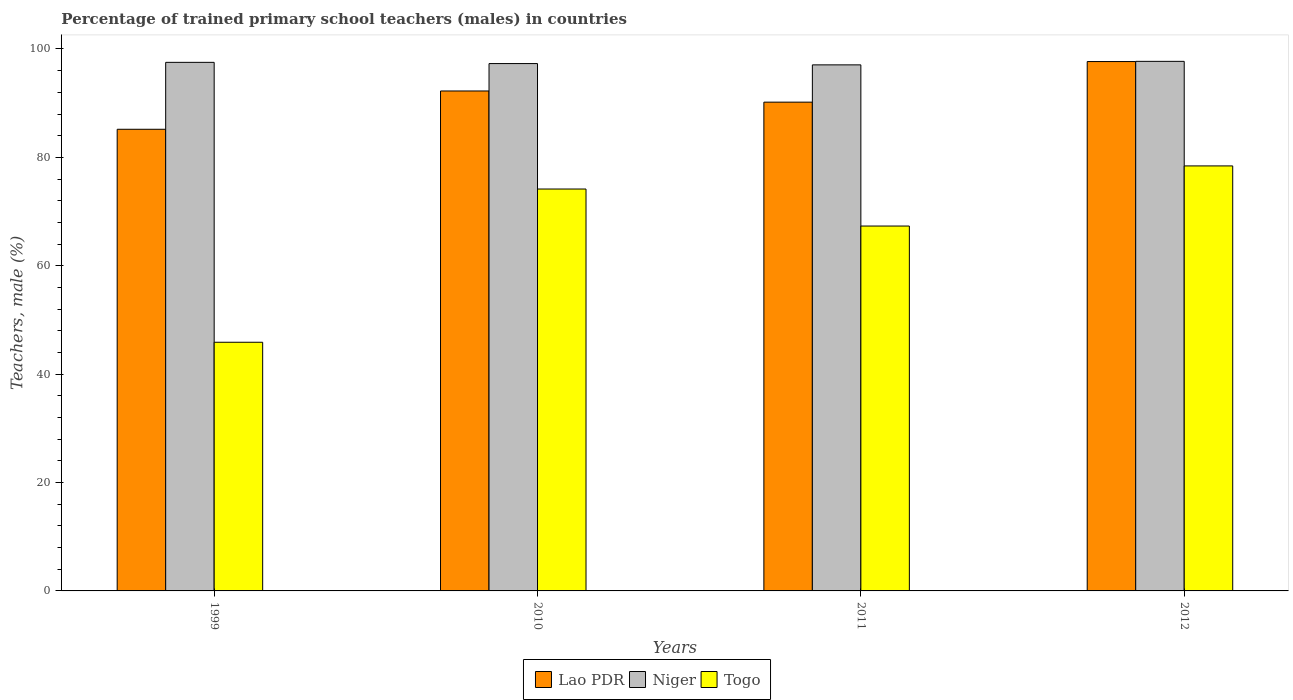How many groups of bars are there?
Your response must be concise. 4. How many bars are there on the 3rd tick from the left?
Make the answer very short. 3. How many bars are there on the 1st tick from the right?
Your response must be concise. 3. What is the label of the 1st group of bars from the left?
Your answer should be compact. 1999. In how many cases, is the number of bars for a given year not equal to the number of legend labels?
Provide a short and direct response. 0. What is the percentage of trained primary school teachers (males) in Niger in 1999?
Give a very brief answer. 97.53. Across all years, what is the maximum percentage of trained primary school teachers (males) in Niger?
Give a very brief answer. 97.72. Across all years, what is the minimum percentage of trained primary school teachers (males) in Togo?
Make the answer very short. 45.88. In which year was the percentage of trained primary school teachers (males) in Niger minimum?
Make the answer very short. 2011. What is the total percentage of trained primary school teachers (males) in Niger in the graph?
Offer a terse response. 389.64. What is the difference between the percentage of trained primary school teachers (males) in Togo in 1999 and that in 2011?
Offer a terse response. -21.45. What is the difference between the percentage of trained primary school teachers (males) in Niger in 2010 and the percentage of trained primary school teachers (males) in Togo in 1999?
Make the answer very short. 51.43. What is the average percentage of trained primary school teachers (males) in Niger per year?
Ensure brevity in your answer.  97.41. In the year 2012, what is the difference between the percentage of trained primary school teachers (males) in Niger and percentage of trained primary school teachers (males) in Lao PDR?
Your answer should be very brief. 0.04. In how many years, is the percentage of trained primary school teachers (males) in Niger greater than 12 %?
Your answer should be very brief. 4. What is the ratio of the percentage of trained primary school teachers (males) in Togo in 2010 to that in 2011?
Ensure brevity in your answer.  1.1. Is the difference between the percentage of trained primary school teachers (males) in Niger in 2010 and 2012 greater than the difference between the percentage of trained primary school teachers (males) in Lao PDR in 2010 and 2012?
Your answer should be compact. Yes. What is the difference between the highest and the second highest percentage of trained primary school teachers (males) in Togo?
Your response must be concise. 4.26. What is the difference between the highest and the lowest percentage of trained primary school teachers (males) in Niger?
Your answer should be very brief. 0.65. What does the 3rd bar from the left in 1999 represents?
Give a very brief answer. Togo. What does the 3rd bar from the right in 2011 represents?
Your response must be concise. Lao PDR. Is it the case that in every year, the sum of the percentage of trained primary school teachers (males) in Lao PDR and percentage of trained primary school teachers (males) in Niger is greater than the percentage of trained primary school teachers (males) in Togo?
Offer a very short reply. Yes. Are all the bars in the graph horizontal?
Keep it short and to the point. No. How many years are there in the graph?
Offer a very short reply. 4. Does the graph contain any zero values?
Offer a terse response. No. Does the graph contain grids?
Your answer should be very brief. No. Where does the legend appear in the graph?
Give a very brief answer. Bottom center. How are the legend labels stacked?
Provide a succinct answer. Horizontal. What is the title of the graph?
Keep it short and to the point. Percentage of trained primary school teachers (males) in countries. Does "Cyprus" appear as one of the legend labels in the graph?
Your answer should be very brief. No. What is the label or title of the X-axis?
Your answer should be very brief. Years. What is the label or title of the Y-axis?
Give a very brief answer. Teachers, male (%). What is the Teachers, male (%) of Lao PDR in 1999?
Provide a short and direct response. 85.19. What is the Teachers, male (%) of Niger in 1999?
Make the answer very short. 97.53. What is the Teachers, male (%) of Togo in 1999?
Your answer should be very brief. 45.88. What is the Teachers, male (%) in Lao PDR in 2010?
Your answer should be very brief. 92.25. What is the Teachers, male (%) in Niger in 2010?
Your response must be concise. 97.31. What is the Teachers, male (%) of Togo in 2010?
Your answer should be very brief. 74.16. What is the Teachers, male (%) of Lao PDR in 2011?
Your answer should be very brief. 90.19. What is the Teachers, male (%) of Niger in 2011?
Your response must be concise. 97.07. What is the Teachers, male (%) of Togo in 2011?
Give a very brief answer. 67.33. What is the Teachers, male (%) of Lao PDR in 2012?
Offer a very short reply. 97.68. What is the Teachers, male (%) of Niger in 2012?
Provide a short and direct response. 97.72. What is the Teachers, male (%) of Togo in 2012?
Offer a terse response. 78.42. Across all years, what is the maximum Teachers, male (%) of Lao PDR?
Offer a very short reply. 97.68. Across all years, what is the maximum Teachers, male (%) in Niger?
Your answer should be compact. 97.72. Across all years, what is the maximum Teachers, male (%) in Togo?
Keep it short and to the point. 78.42. Across all years, what is the minimum Teachers, male (%) of Lao PDR?
Offer a terse response. 85.19. Across all years, what is the minimum Teachers, male (%) in Niger?
Your response must be concise. 97.07. Across all years, what is the minimum Teachers, male (%) in Togo?
Give a very brief answer. 45.88. What is the total Teachers, male (%) in Lao PDR in the graph?
Give a very brief answer. 365.31. What is the total Teachers, male (%) in Niger in the graph?
Offer a very short reply. 389.64. What is the total Teachers, male (%) of Togo in the graph?
Offer a terse response. 265.8. What is the difference between the Teachers, male (%) in Lao PDR in 1999 and that in 2010?
Your answer should be very brief. -7.07. What is the difference between the Teachers, male (%) of Niger in 1999 and that in 2010?
Offer a very short reply. 0.22. What is the difference between the Teachers, male (%) of Togo in 1999 and that in 2010?
Give a very brief answer. -28.28. What is the difference between the Teachers, male (%) of Lao PDR in 1999 and that in 2011?
Offer a terse response. -5.01. What is the difference between the Teachers, male (%) of Niger in 1999 and that in 2011?
Give a very brief answer. 0.46. What is the difference between the Teachers, male (%) in Togo in 1999 and that in 2011?
Your answer should be very brief. -21.45. What is the difference between the Teachers, male (%) of Lao PDR in 1999 and that in 2012?
Your response must be concise. -12.5. What is the difference between the Teachers, male (%) of Niger in 1999 and that in 2012?
Your response must be concise. -0.19. What is the difference between the Teachers, male (%) in Togo in 1999 and that in 2012?
Ensure brevity in your answer.  -32.54. What is the difference between the Teachers, male (%) in Lao PDR in 2010 and that in 2011?
Your answer should be compact. 2.06. What is the difference between the Teachers, male (%) of Niger in 2010 and that in 2011?
Offer a terse response. 0.24. What is the difference between the Teachers, male (%) of Togo in 2010 and that in 2011?
Your answer should be compact. 6.83. What is the difference between the Teachers, male (%) of Lao PDR in 2010 and that in 2012?
Your response must be concise. -5.43. What is the difference between the Teachers, male (%) of Niger in 2010 and that in 2012?
Your answer should be compact. -0.41. What is the difference between the Teachers, male (%) in Togo in 2010 and that in 2012?
Your response must be concise. -4.26. What is the difference between the Teachers, male (%) of Lao PDR in 2011 and that in 2012?
Make the answer very short. -7.49. What is the difference between the Teachers, male (%) of Niger in 2011 and that in 2012?
Your answer should be very brief. -0.65. What is the difference between the Teachers, male (%) of Togo in 2011 and that in 2012?
Make the answer very short. -11.09. What is the difference between the Teachers, male (%) of Lao PDR in 1999 and the Teachers, male (%) of Niger in 2010?
Provide a short and direct response. -12.12. What is the difference between the Teachers, male (%) of Lao PDR in 1999 and the Teachers, male (%) of Togo in 2010?
Provide a short and direct response. 11.03. What is the difference between the Teachers, male (%) in Niger in 1999 and the Teachers, male (%) in Togo in 2010?
Offer a terse response. 23.37. What is the difference between the Teachers, male (%) in Lao PDR in 1999 and the Teachers, male (%) in Niger in 2011?
Your answer should be compact. -11.89. What is the difference between the Teachers, male (%) in Lao PDR in 1999 and the Teachers, male (%) in Togo in 2011?
Offer a very short reply. 17.86. What is the difference between the Teachers, male (%) of Niger in 1999 and the Teachers, male (%) of Togo in 2011?
Offer a very short reply. 30.2. What is the difference between the Teachers, male (%) in Lao PDR in 1999 and the Teachers, male (%) in Niger in 2012?
Give a very brief answer. -12.53. What is the difference between the Teachers, male (%) in Lao PDR in 1999 and the Teachers, male (%) in Togo in 2012?
Keep it short and to the point. 6.76. What is the difference between the Teachers, male (%) of Niger in 1999 and the Teachers, male (%) of Togo in 2012?
Give a very brief answer. 19.11. What is the difference between the Teachers, male (%) of Lao PDR in 2010 and the Teachers, male (%) of Niger in 2011?
Make the answer very short. -4.82. What is the difference between the Teachers, male (%) in Lao PDR in 2010 and the Teachers, male (%) in Togo in 2011?
Make the answer very short. 24.92. What is the difference between the Teachers, male (%) of Niger in 2010 and the Teachers, male (%) of Togo in 2011?
Keep it short and to the point. 29.98. What is the difference between the Teachers, male (%) in Lao PDR in 2010 and the Teachers, male (%) in Niger in 2012?
Make the answer very short. -5.47. What is the difference between the Teachers, male (%) of Lao PDR in 2010 and the Teachers, male (%) of Togo in 2012?
Your answer should be very brief. 13.83. What is the difference between the Teachers, male (%) of Niger in 2010 and the Teachers, male (%) of Togo in 2012?
Provide a succinct answer. 18.89. What is the difference between the Teachers, male (%) of Lao PDR in 2011 and the Teachers, male (%) of Niger in 2012?
Ensure brevity in your answer.  -7.53. What is the difference between the Teachers, male (%) in Lao PDR in 2011 and the Teachers, male (%) in Togo in 2012?
Give a very brief answer. 11.77. What is the difference between the Teachers, male (%) of Niger in 2011 and the Teachers, male (%) of Togo in 2012?
Your answer should be very brief. 18.65. What is the average Teachers, male (%) of Lao PDR per year?
Provide a succinct answer. 91.33. What is the average Teachers, male (%) in Niger per year?
Keep it short and to the point. 97.41. What is the average Teachers, male (%) of Togo per year?
Offer a terse response. 66.45. In the year 1999, what is the difference between the Teachers, male (%) in Lao PDR and Teachers, male (%) in Niger?
Ensure brevity in your answer.  -12.35. In the year 1999, what is the difference between the Teachers, male (%) of Lao PDR and Teachers, male (%) of Togo?
Provide a short and direct response. 39.3. In the year 1999, what is the difference between the Teachers, male (%) of Niger and Teachers, male (%) of Togo?
Provide a short and direct response. 51.65. In the year 2010, what is the difference between the Teachers, male (%) of Lao PDR and Teachers, male (%) of Niger?
Make the answer very short. -5.06. In the year 2010, what is the difference between the Teachers, male (%) in Lao PDR and Teachers, male (%) in Togo?
Provide a succinct answer. 18.09. In the year 2010, what is the difference between the Teachers, male (%) in Niger and Teachers, male (%) in Togo?
Make the answer very short. 23.15. In the year 2011, what is the difference between the Teachers, male (%) in Lao PDR and Teachers, male (%) in Niger?
Give a very brief answer. -6.88. In the year 2011, what is the difference between the Teachers, male (%) of Lao PDR and Teachers, male (%) of Togo?
Offer a very short reply. 22.86. In the year 2011, what is the difference between the Teachers, male (%) in Niger and Teachers, male (%) in Togo?
Provide a succinct answer. 29.74. In the year 2012, what is the difference between the Teachers, male (%) in Lao PDR and Teachers, male (%) in Niger?
Your answer should be very brief. -0.04. In the year 2012, what is the difference between the Teachers, male (%) in Lao PDR and Teachers, male (%) in Togo?
Offer a terse response. 19.26. In the year 2012, what is the difference between the Teachers, male (%) of Niger and Teachers, male (%) of Togo?
Offer a very short reply. 19.3. What is the ratio of the Teachers, male (%) in Lao PDR in 1999 to that in 2010?
Make the answer very short. 0.92. What is the ratio of the Teachers, male (%) of Niger in 1999 to that in 2010?
Ensure brevity in your answer.  1. What is the ratio of the Teachers, male (%) in Togo in 1999 to that in 2010?
Make the answer very short. 0.62. What is the ratio of the Teachers, male (%) in Lao PDR in 1999 to that in 2011?
Make the answer very short. 0.94. What is the ratio of the Teachers, male (%) in Togo in 1999 to that in 2011?
Offer a terse response. 0.68. What is the ratio of the Teachers, male (%) of Lao PDR in 1999 to that in 2012?
Give a very brief answer. 0.87. What is the ratio of the Teachers, male (%) of Niger in 1999 to that in 2012?
Provide a short and direct response. 1. What is the ratio of the Teachers, male (%) of Togo in 1999 to that in 2012?
Your answer should be compact. 0.59. What is the ratio of the Teachers, male (%) in Lao PDR in 2010 to that in 2011?
Provide a succinct answer. 1.02. What is the ratio of the Teachers, male (%) of Niger in 2010 to that in 2011?
Give a very brief answer. 1. What is the ratio of the Teachers, male (%) in Togo in 2010 to that in 2011?
Keep it short and to the point. 1.1. What is the ratio of the Teachers, male (%) in Lao PDR in 2010 to that in 2012?
Your answer should be compact. 0.94. What is the ratio of the Teachers, male (%) of Togo in 2010 to that in 2012?
Your response must be concise. 0.95. What is the ratio of the Teachers, male (%) in Lao PDR in 2011 to that in 2012?
Make the answer very short. 0.92. What is the ratio of the Teachers, male (%) in Niger in 2011 to that in 2012?
Keep it short and to the point. 0.99. What is the ratio of the Teachers, male (%) in Togo in 2011 to that in 2012?
Provide a short and direct response. 0.86. What is the difference between the highest and the second highest Teachers, male (%) of Lao PDR?
Ensure brevity in your answer.  5.43. What is the difference between the highest and the second highest Teachers, male (%) in Niger?
Offer a very short reply. 0.19. What is the difference between the highest and the second highest Teachers, male (%) in Togo?
Ensure brevity in your answer.  4.26. What is the difference between the highest and the lowest Teachers, male (%) in Lao PDR?
Offer a very short reply. 12.5. What is the difference between the highest and the lowest Teachers, male (%) of Niger?
Ensure brevity in your answer.  0.65. What is the difference between the highest and the lowest Teachers, male (%) of Togo?
Offer a very short reply. 32.54. 